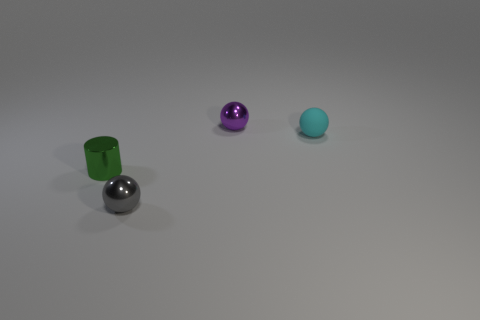Add 4 red metallic cylinders. How many objects exist? 8 Subtract all spheres. How many objects are left? 1 Subtract 0 brown cylinders. How many objects are left? 4 Subtract all gray shiny balls. Subtract all green objects. How many objects are left? 2 Add 4 cyan matte things. How many cyan matte things are left? 5 Add 3 green matte things. How many green matte things exist? 3 